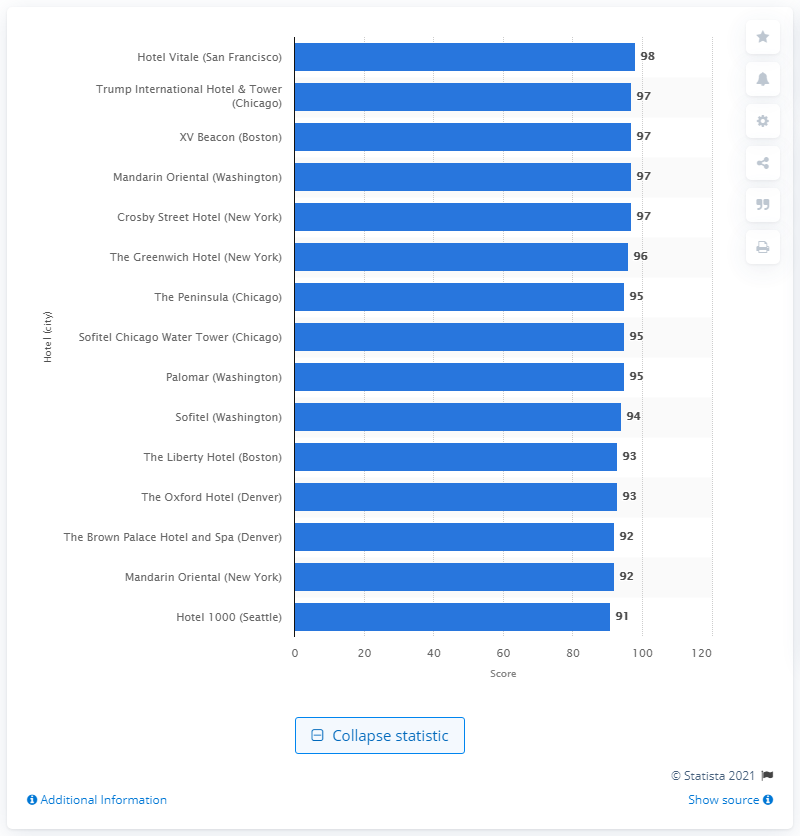Mention a couple of crucial points in this snapshot. The score of The Hotel Vitale was 98.. 